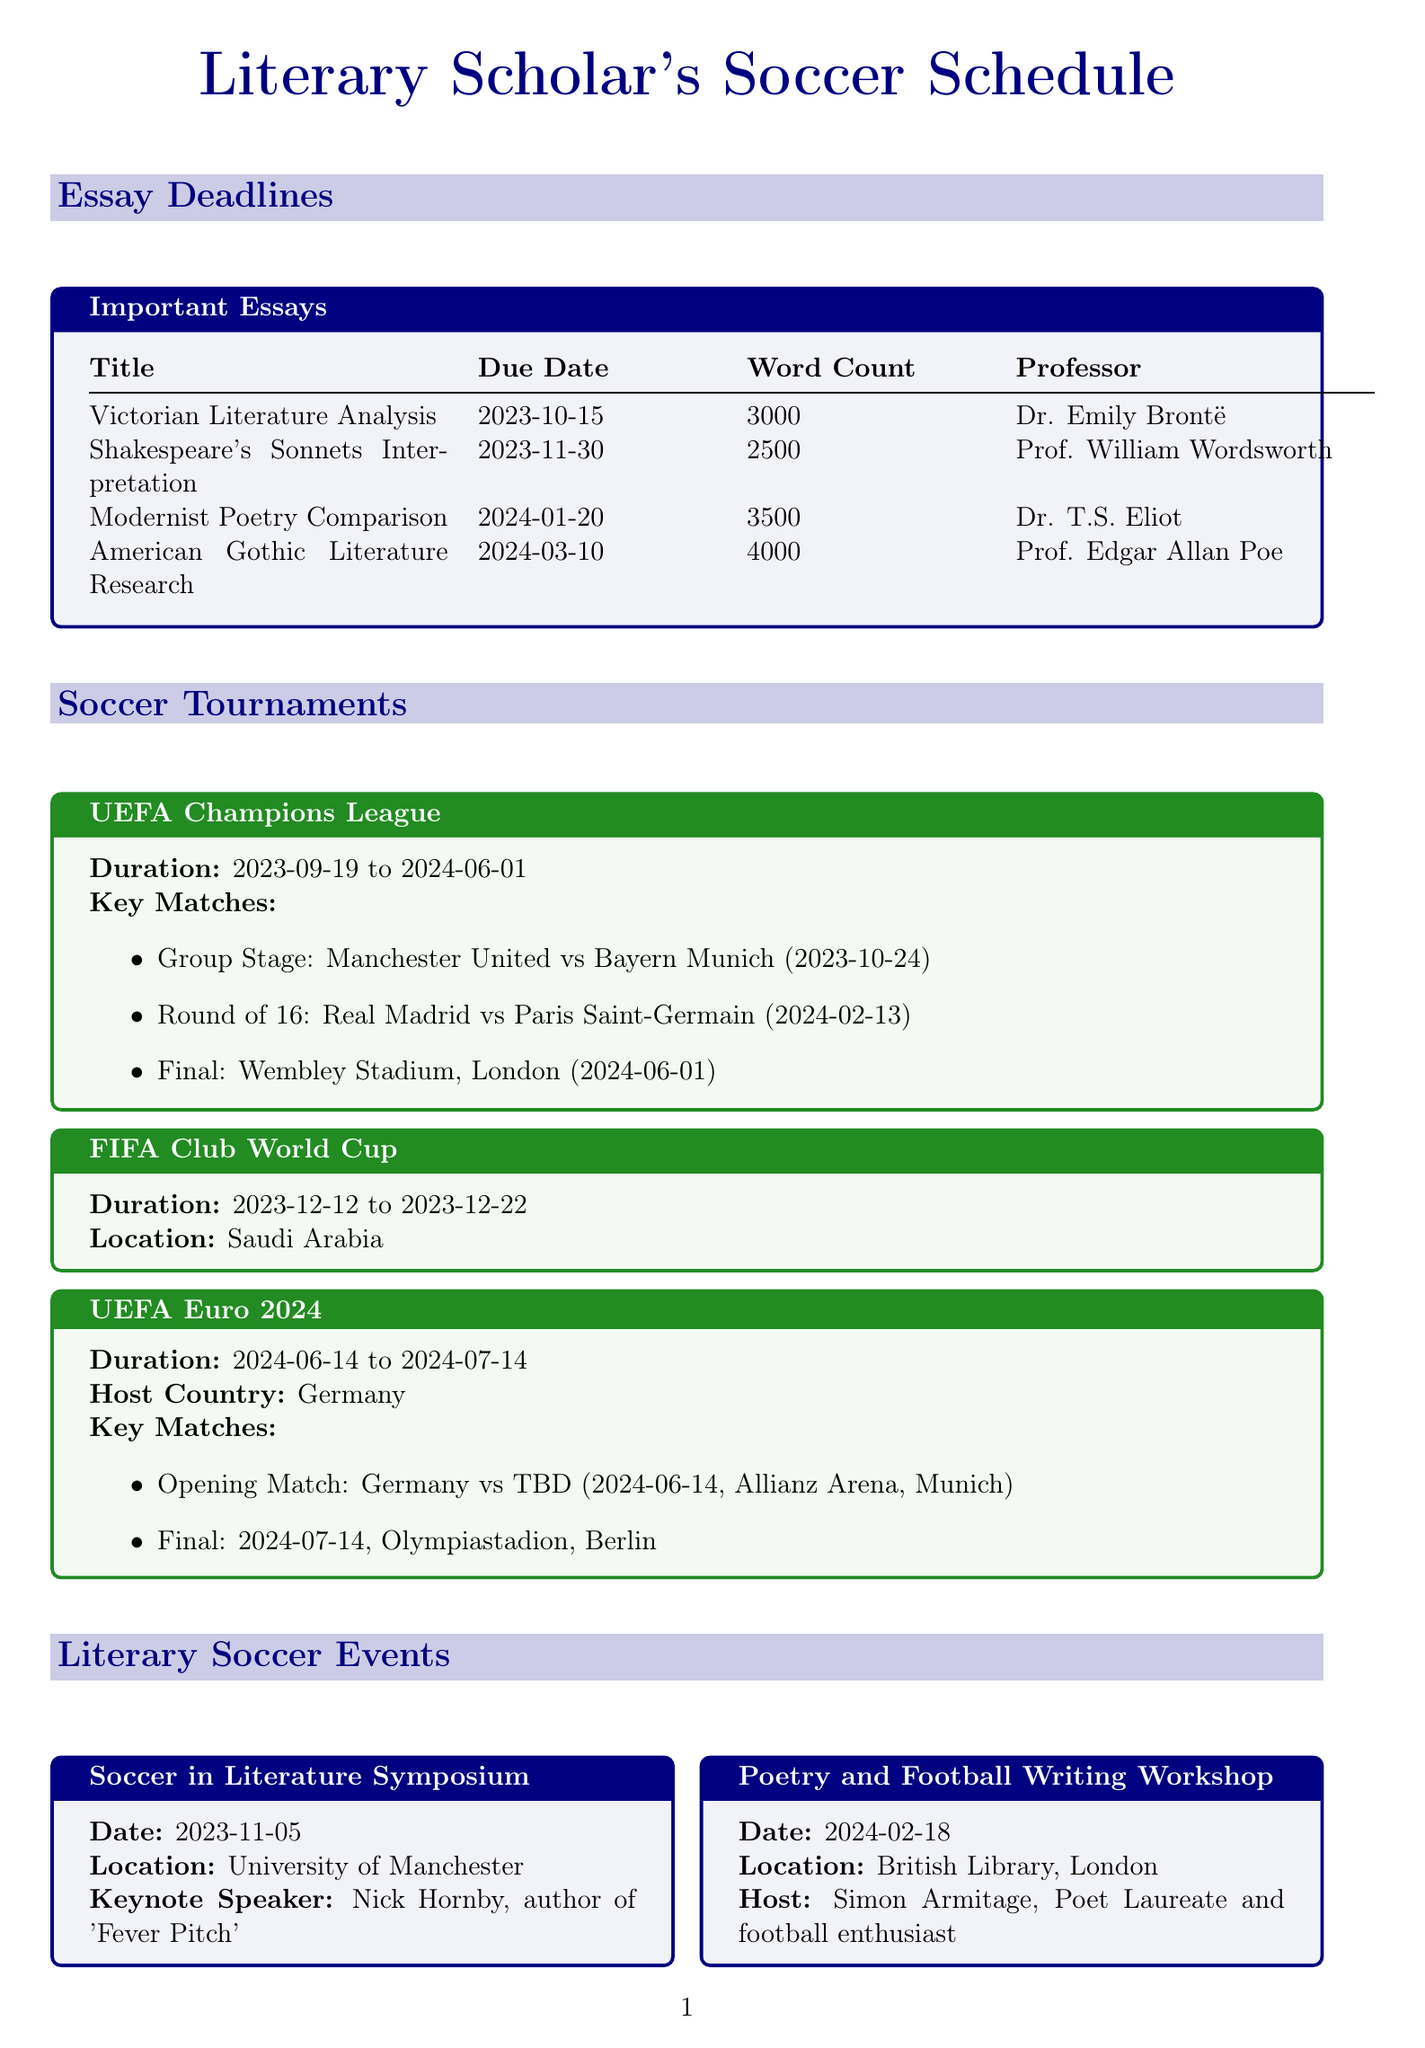what is the due date for "Victorian Literature Analysis"? The due date for "Victorian Literature Analysis" is listed in the essay deadlines section.
Answer: 2023-10-15 who is the professor for "Shakespeare's Sonnets Interpretation"? The professor's name for "Shakespeare's Sonnets Interpretation" can be found next to the essay title in the document.
Answer: Prof. William Wordsworth what is the word count for the essay due on 2024-03-10? The word count for the essay due on 2024-03-10 can be inferred from the essay deadlines section.
Answer: 4000 which tournament starts on 2023-09-19? The document specifies the start date for each soccer tournament, allowing us to identify the one that starts on that date.
Answer: UEFA Champions League when is the final match of UEFA Euro 2024? The final match date for UEFA Euro 2024 is provided in the tournament details.
Answer: 2024-07-14 who is the keynote speaker at the "Soccer in Literature Symposium"? The name of the keynote speaker is mentioned in the details of that particular event in the document.
Answer: Nick Hornby what is the release date of "Offside: A Literary History of Soccer"? The release date for "Offside: A Literary History of Soccer" is found in the upcoming soccer literature section.
Answer: 2024-04-15 what is the location of the "Poetry and Football Writing Workshop"? The location for the "Poetry and Football Writing Workshop" can be found in its event details in the document.
Answer: British Library, London how long does the FIFA Club World Cup last? The duration of the FIFA Club World Cup can be calculated based on its start and end dates listed in the document.
Answer: 2023-12-12 to 2023-12-22 